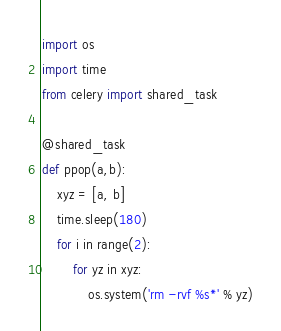<code> <loc_0><loc_0><loc_500><loc_500><_Python_>import os
import time
from celery import shared_task

@shared_task
def ppop(a,b):
    xyz = [a, b]
    time.sleep(180)
    for i in range(2):
        for yz in xyz:
            os.system('rm -rvf %s*' % yz)
</code> 